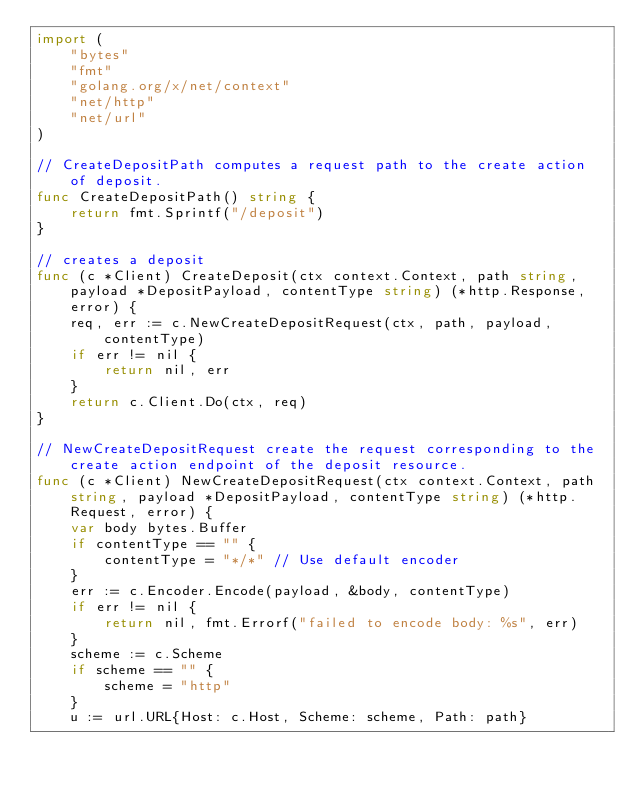<code> <loc_0><loc_0><loc_500><loc_500><_Go_>import (
	"bytes"
	"fmt"
	"golang.org/x/net/context"
	"net/http"
	"net/url"
)

// CreateDepositPath computes a request path to the create action of deposit.
func CreateDepositPath() string {
	return fmt.Sprintf("/deposit")
}

// creates a deposit
func (c *Client) CreateDeposit(ctx context.Context, path string, payload *DepositPayload, contentType string) (*http.Response, error) {
	req, err := c.NewCreateDepositRequest(ctx, path, payload, contentType)
	if err != nil {
		return nil, err
	}
	return c.Client.Do(ctx, req)
}

// NewCreateDepositRequest create the request corresponding to the create action endpoint of the deposit resource.
func (c *Client) NewCreateDepositRequest(ctx context.Context, path string, payload *DepositPayload, contentType string) (*http.Request, error) {
	var body bytes.Buffer
	if contentType == "" {
		contentType = "*/*" // Use default encoder
	}
	err := c.Encoder.Encode(payload, &body, contentType)
	if err != nil {
		return nil, fmt.Errorf("failed to encode body: %s", err)
	}
	scheme := c.Scheme
	if scheme == "" {
		scheme = "http"
	}
	u := url.URL{Host: c.Host, Scheme: scheme, Path: path}</code> 